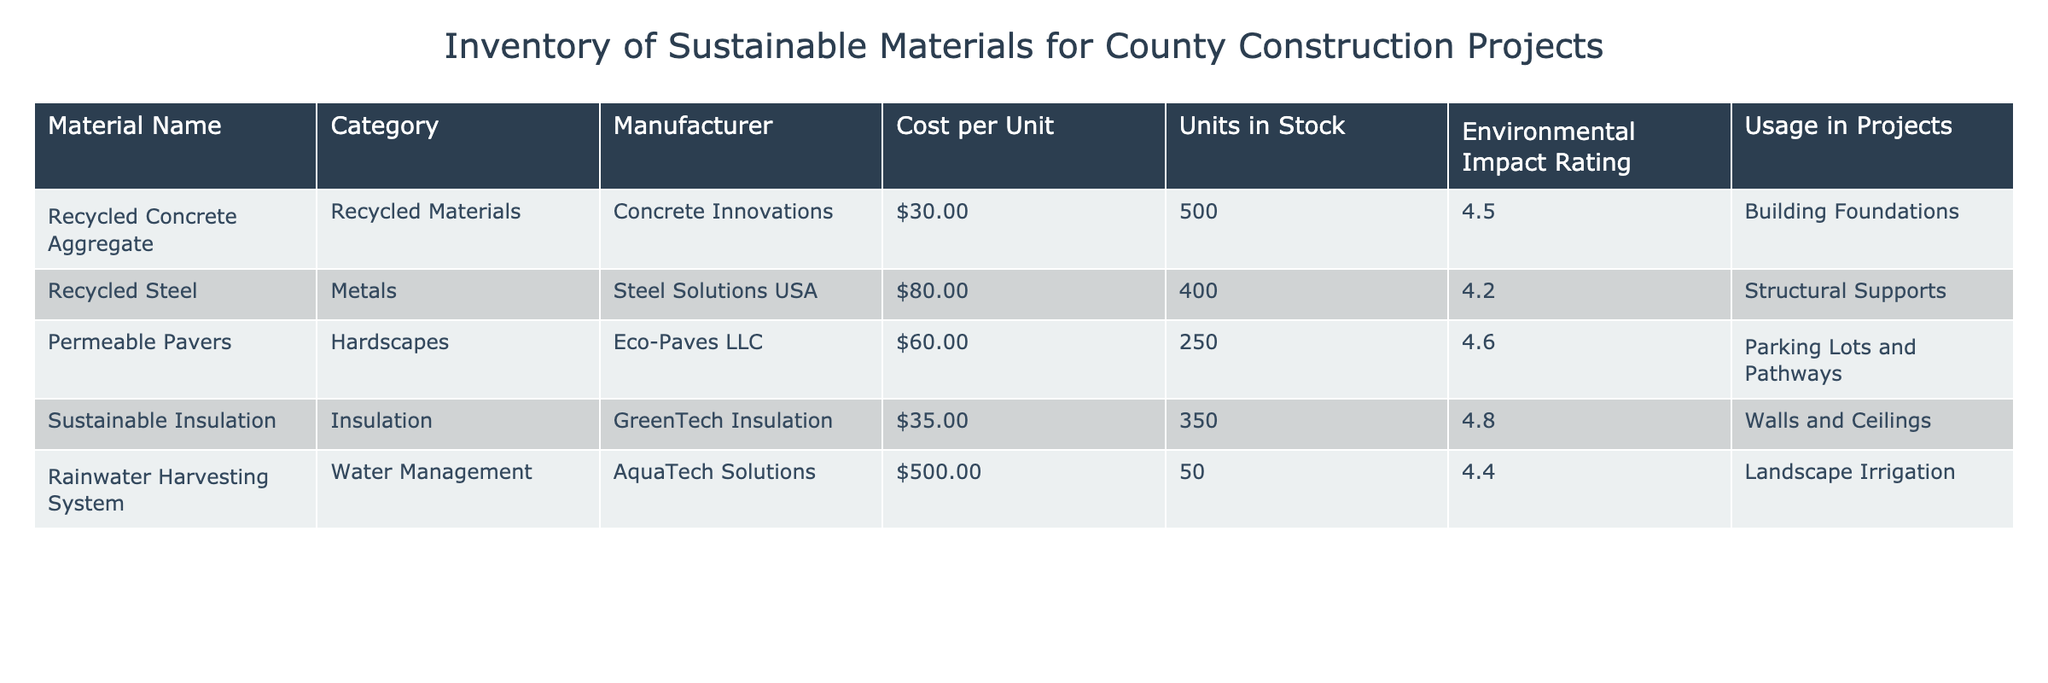What is the cost per unit of Recycled Steel? The cost per unit for Recycled Steel is listed directly in the table under the "Cost per Unit" column corresponding to the "Recycled Steel" row. It shows $80.00.
Answer: $80.00 How many units of Sustainable Insulation are in stock? The number of units in stock for Sustainable Insulation can be found in the "Units in Stock" column for the respective row. It indicates there are 350 units available.
Answer: 350 Which material has the highest Environmental Impact Rating? To find the highest Environmental Impact Rating, I look through the "Environmental Impact Rating" column. The maximum rating is 4.8, which belongs to Sustainable Insulation.
Answer: Sustainable Insulation What is the total cost of all materials in stock? First, I calculate the total cost for each material by multiplying the cost per unit by the units in stock. Then, summing these products: (30 * 500) + (80 * 400) + (60 * 250) + (35 * 350) + (500 * 50) = 15000 + 32000 + 15000 + 12250 + 25000 = 99250.
Answer: $99,250 Is there any material that has an Environmental Impact Rating of over 4.5? I will examine the "Environmental Impact Rating" column to see if there are entries greater than 4.5. Recycled Concrete Aggregate, Permeable Pavers, and Sustainable Insulation all have ratings above 4.5. This means there are materials with ratings over 4.5.
Answer: Yes What is the average cost per unit of all materials? To find the average cost per unit, I first sum the costs: 30 + 80 + 60 + 35 + 500 = 705. There are five materials, so I divide the total cost by the number of materials: 705 / 5 = 141.
Answer: $141.00 Which material is used for 'Building Foundations'? By looking at the "Usage in Projects" column, I identify that "Recycled Concrete Aggregate" is specified for 'Building Foundations'.
Answer: Recycled Concrete Aggregate How many total units of Recycled Materials are available? I identify all items in the "Recycled Materials" category (Recycled Concrete Aggregate is one), and look at their corresponding "Units in Stock": 500. There are no other recycled materials, so the total is just 500.
Answer: 500 